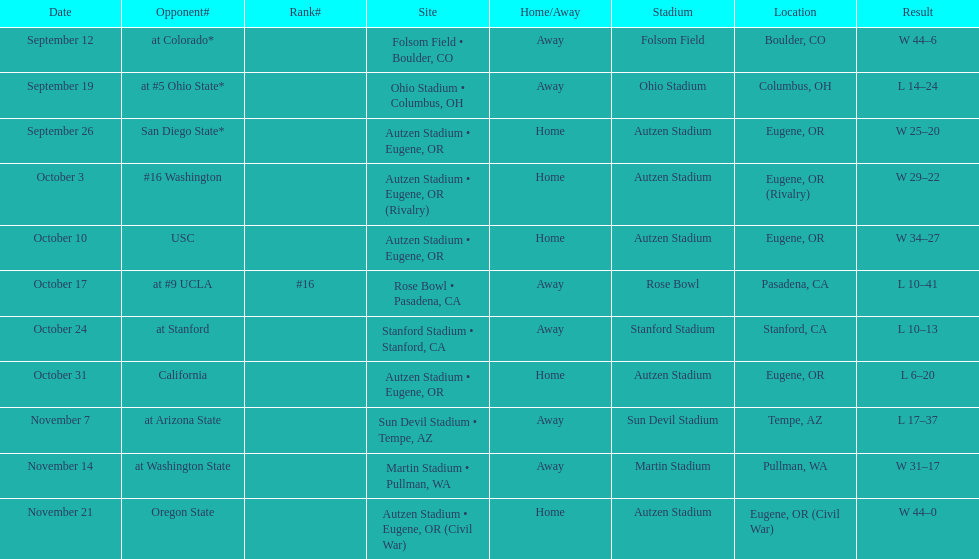Between september 26 and october 24, how many games were played in eugene, or? 3. 